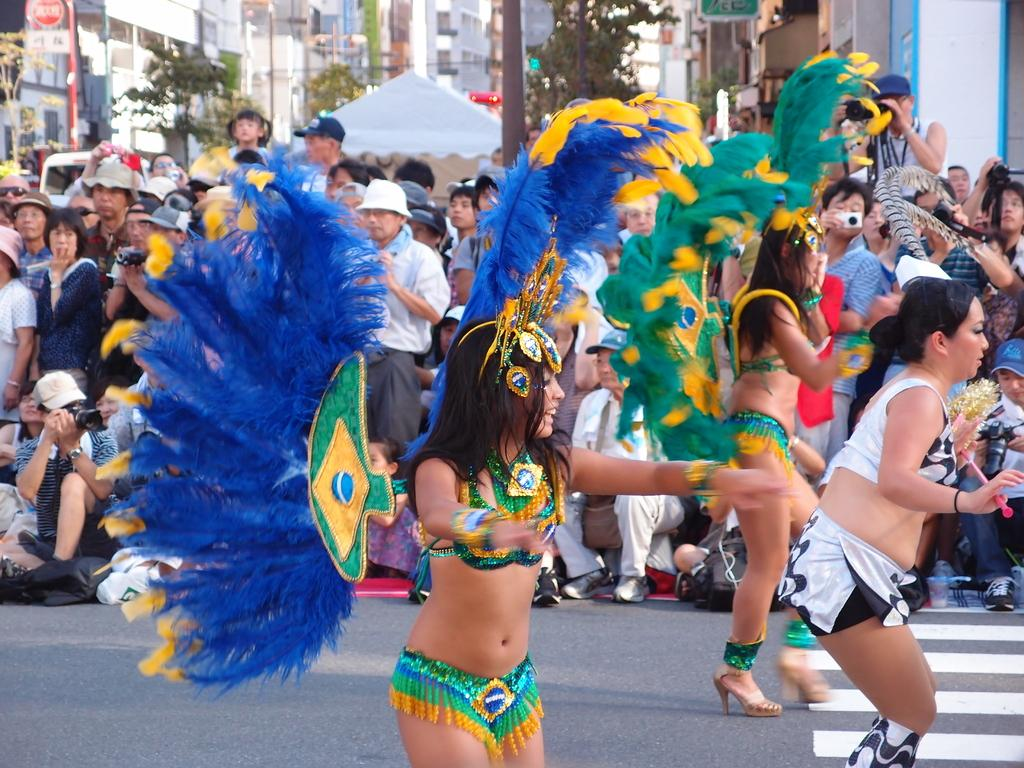What are the women in the image doing? The women in the image are dancing. Where are they dancing? They are dancing on the road. What can be seen in the background of the image? There is a crowd, a pole, a tent, trees, and buildings in the background of the image. What type of lumber is being used to create a scarf for the dancers in the image? There is no lumber or scarf present in the image; the women are dancing without any visible accessories. 